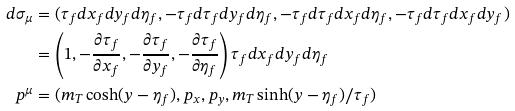Convert formula to latex. <formula><loc_0><loc_0><loc_500><loc_500>d \sigma _ { \mu } & = ( \tau _ { f } d x _ { f } d y _ { f } d \eta _ { f } , - \tau _ { f } d \tau _ { f } d y _ { f } d \eta _ { f } , - \tau _ { f } d \tau _ { f } d x _ { f } d \eta _ { f } , - \tau _ { f } d \tau _ { f } d x _ { f } d y _ { f } ) \\ & = \left ( 1 , - \frac { \partial \tau _ { f } } { \partial x _ { f } } , - \frac { \partial \tau _ { f } } { \partial y _ { f } } , - \frac { \partial \tau _ { f } } { \partial \eta _ { f } } \right ) \tau _ { f } d x _ { f } d y _ { f } d \eta _ { f } \\ p ^ { \mu } & = ( m _ { T } \cosh ( y - \eta _ { f } ) , p _ { x } , p _ { y } , m _ { T } \sinh ( y - \eta _ { f } ) / \tau _ { f } )</formula> 